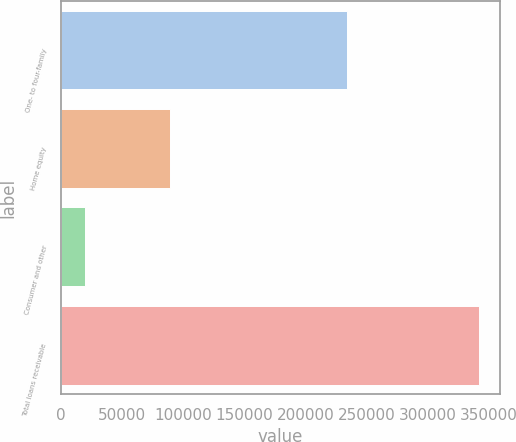Convert chart. <chart><loc_0><loc_0><loc_500><loc_500><bar_chart><fcel>One- to four-family<fcel>Home equity<fcel>Consumer and other<fcel>Total loans receivable<nl><fcel>233796<fcel>89347<fcel>19101<fcel>342244<nl></chart> 